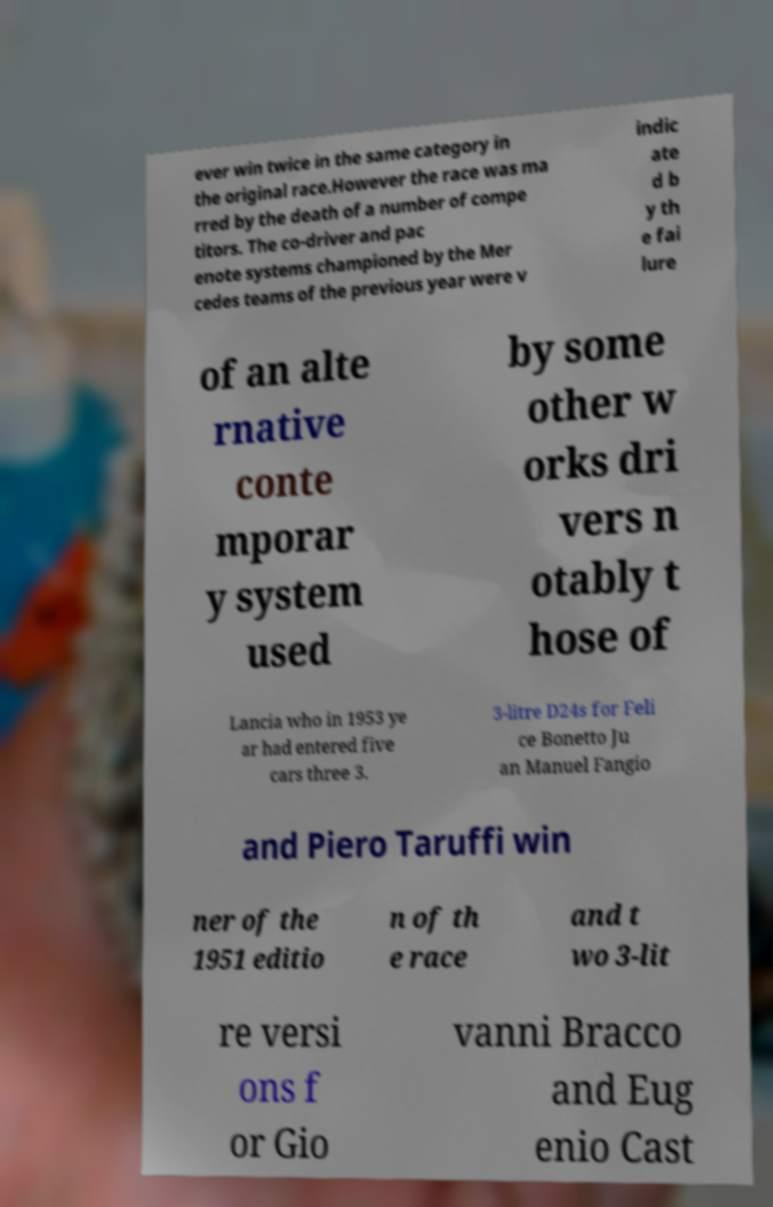Could you extract and type out the text from this image? ever win twice in the same category in the original race.However the race was ma rred by the death of a number of compe titors. The co-driver and pac enote systems championed by the Mer cedes teams of the previous year were v indic ate d b y th e fai lure of an alte rnative conte mporar y system used by some other w orks dri vers n otably t hose of Lancia who in 1953 ye ar had entered five cars three 3. 3-litre D24s for Feli ce Bonetto Ju an Manuel Fangio and Piero Taruffi win ner of the 1951 editio n of th e race and t wo 3-lit re versi ons f or Gio vanni Bracco and Eug enio Cast 